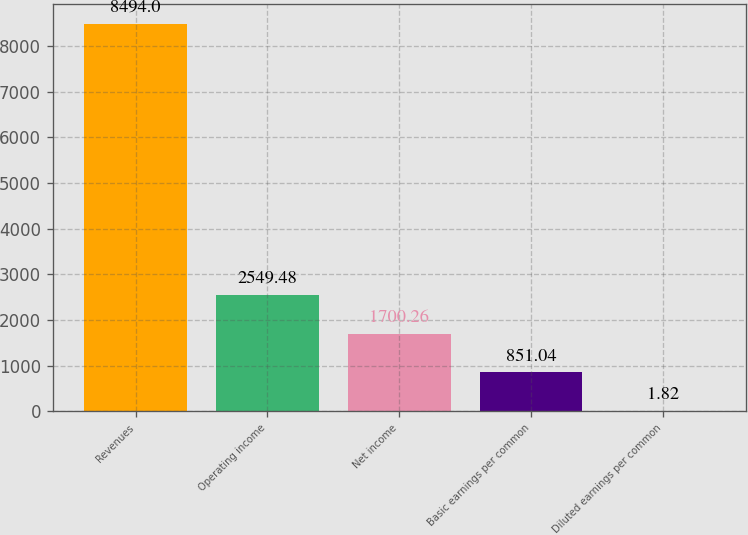Convert chart. <chart><loc_0><loc_0><loc_500><loc_500><bar_chart><fcel>Revenues<fcel>Operating income<fcel>Net income<fcel>Basic earnings per common<fcel>Diluted earnings per common<nl><fcel>8494<fcel>2549.48<fcel>1700.26<fcel>851.04<fcel>1.82<nl></chart> 